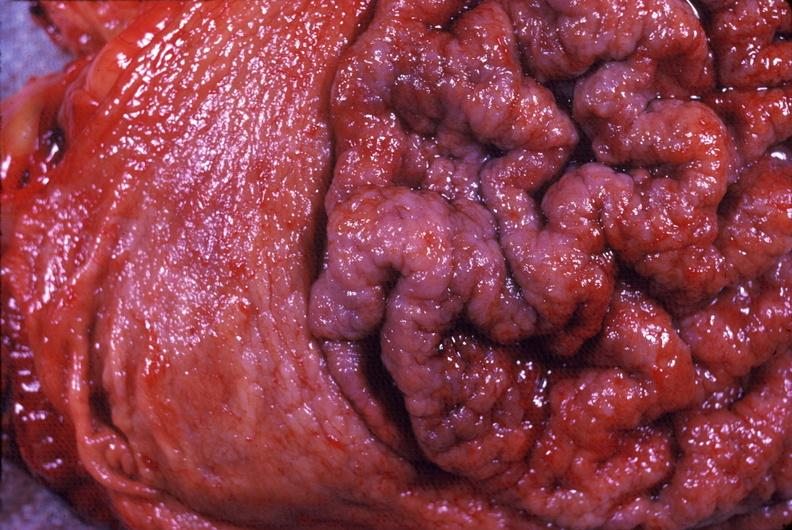s gastrointestinal present?
Answer the question using a single word or phrase. Yes 